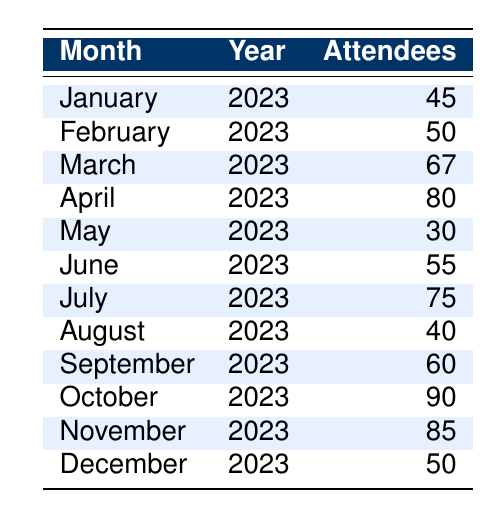What was the highest number of attendees at healthcare workshops in 2023? The highest number of attendees is found by scanning the "Attendees" column for the maximum value. The highest value is 90, which occurred in October 2023.
Answer: 90 Which month had the lowest attendance in 2023? To find the month with the lowest attendance, we look for the minimum value in the "Attendees" column. The lowest value is 30, which was in May 2023.
Answer: May What is the average attendance rate for the workshops over the year? To calculate the average attendance, we sum up all the attendees: (45 + 50 + 67 + 80 + 30 + 55 + 75 + 40 + 60 + 90 + 85 + 50) =  877. There are 12 months, so the average is 877/12 = approximately 73.08.
Answer: 73.08 Did attendance increase from January to October? We compare the attendance values for January (45) and October (90). Since 90 is greater than 45, we conclude that attendance did increase over this period.
Answer: Yes What is the difference in attendance between the months with the highest and lowest attendees? The highest attendance is 90 in October, and the lowest is 30 in May. The difference is calculated as 90 - 30 = 60.
Answer: 60 How many months had attendance above 60? We review the "Attendees" column to count the months where attendance exceeds 60. These months are March (67), April (80), July (75), October (90), and November (85). This totals to 5 months.
Answer: 5 Is it true that February had more attendees than August? Checking the attendance for February (50) and August (40), we confirm that February has greater attendance than August.
Answer: Yes What was the total attendance from June to December? We add the attendance values from June (55) to December (50): 55 + 75 + 40 + 60 + 90 + 85 + 50 = 455.
Answer: 455 How many months had an attendance rate of less than 50? We review the "Attendees" column for values below 50: January (45), May (30), and August (40). This totals to 3 months.
Answer: 3 